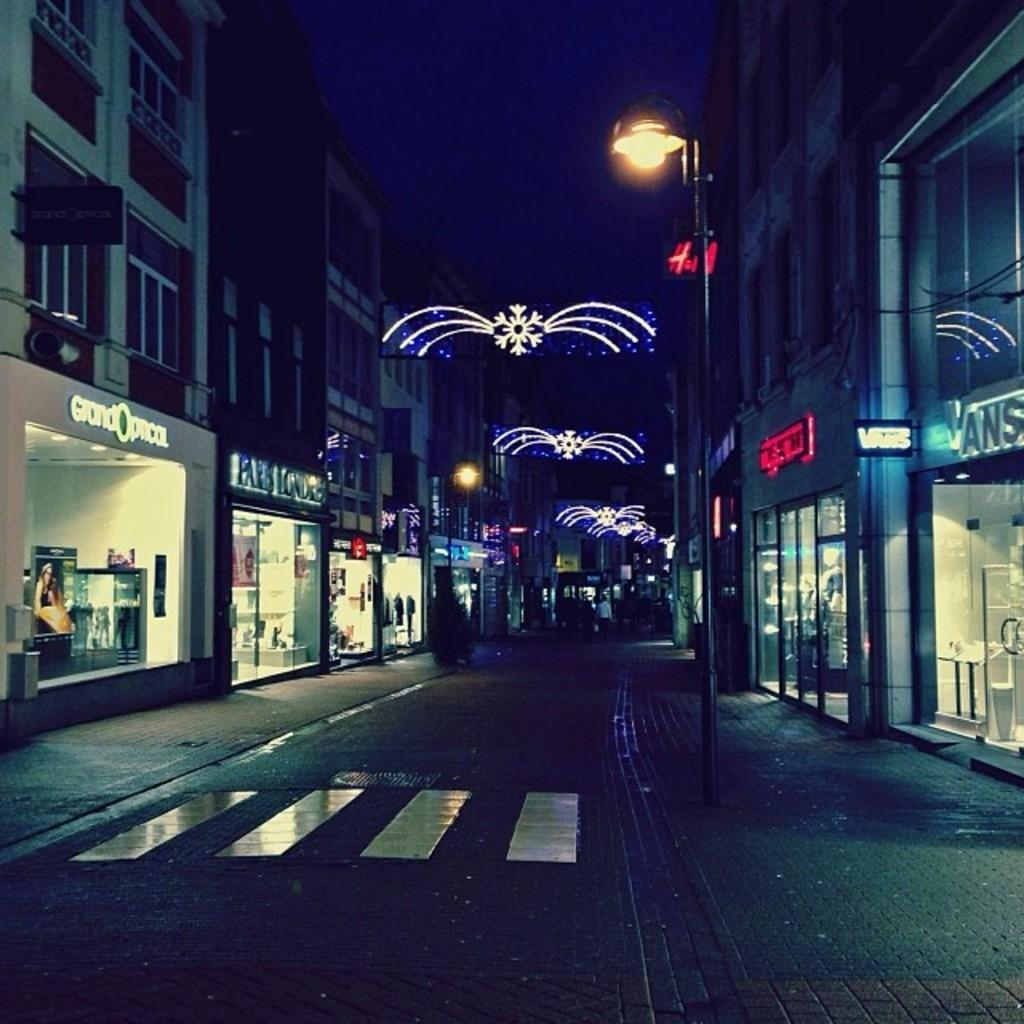What is the main object in the middle of the image? There is a pole in the middle of the image. What is attached to the pole? There is a light on the pole. What type of structures can be seen in the image? Buildings are visible in the image. What activity is happening behind the pole? People are walking on the road behind the pole. Can you see any cattle grazing near the pole in the image? There are no cattle present in the image. What type of sugar is being used to sweeten the light on the pole? The light on the pole does not require sugar, as it is an electrical light. 